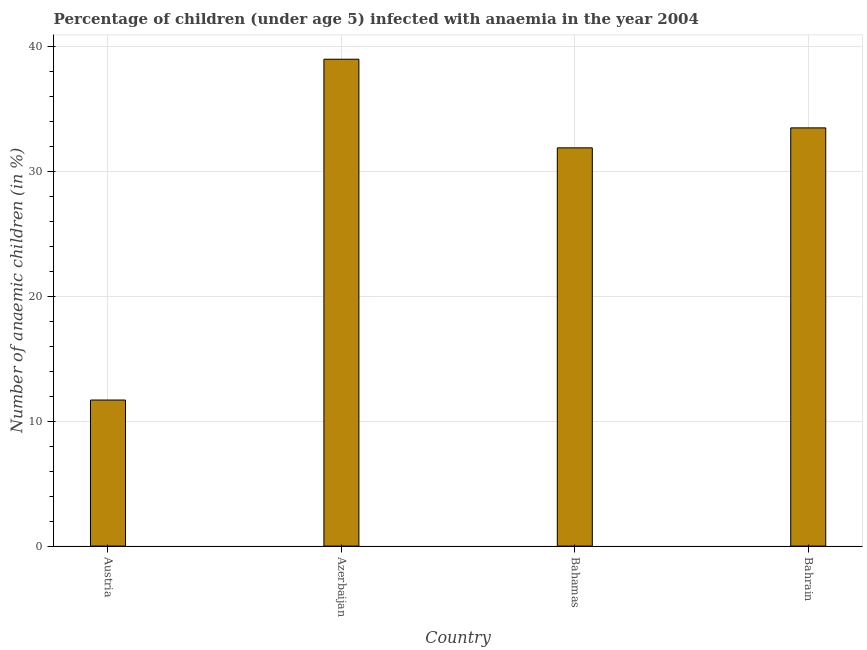What is the title of the graph?
Ensure brevity in your answer.  Percentage of children (under age 5) infected with anaemia in the year 2004. What is the label or title of the Y-axis?
Give a very brief answer. Number of anaemic children (in %). What is the number of anaemic children in Bahrain?
Provide a succinct answer. 33.5. Across all countries, what is the minimum number of anaemic children?
Provide a short and direct response. 11.7. In which country was the number of anaemic children maximum?
Make the answer very short. Azerbaijan. What is the sum of the number of anaemic children?
Ensure brevity in your answer.  116.1. What is the difference between the number of anaemic children in Austria and Bahamas?
Offer a terse response. -20.2. What is the average number of anaemic children per country?
Provide a short and direct response. 29.02. What is the median number of anaemic children?
Offer a very short reply. 32.7. In how many countries, is the number of anaemic children greater than 28 %?
Make the answer very short. 3. Is the number of anaemic children in Azerbaijan less than that in Bahrain?
Provide a short and direct response. No. What is the difference between the highest and the lowest number of anaemic children?
Your answer should be very brief. 27.3. Are all the bars in the graph horizontal?
Keep it short and to the point. No. How many countries are there in the graph?
Give a very brief answer. 4. What is the difference between two consecutive major ticks on the Y-axis?
Offer a very short reply. 10. Are the values on the major ticks of Y-axis written in scientific E-notation?
Offer a very short reply. No. What is the Number of anaemic children (in %) of Austria?
Keep it short and to the point. 11.7. What is the Number of anaemic children (in %) in Bahamas?
Your answer should be compact. 31.9. What is the Number of anaemic children (in %) in Bahrain?
Offer a terse response. 33.5. What is the difference between the Number of anaemic children (in %) in Austria and Azerbaijan?
Give a very brief answer. -27.3. What is the difference between the Number of anaemic children (in %) in Austria and Bahamas?
Ensure brevity in your answer.  -20.2. What is the difference between the Number of anaemic children (in %) in Austria and Bahrain?
Give a very brief answer. -21.8. What is the difference between the Number of anaemic children (in %) in Azerbaijan and Bahrain?
Make the answer very short. 5.5. What is the difference between the Number of anaemic children (in %) in Bahamas and Bahrain?
Keep it short and to the point. -1.6. What is the ratio of the Number of anaemic children (in %) in Austria to that in Bahamas?
Offer a terse response. 0.37. What is the ratio of the Number of anaemic children (in %) in Austria to that in Bahrain?
Keep it short and to the point. 0.35. What is the ratio of the Number of anaemic children (in %) in Azerbaijan to that in Bahamas?
Make the answer very short. 1.22. What is the ratio of the Number of anaemic children (in %) in Azerbaijan to that in Bahrain?
Give a very brief answer. 1.16. What is the ratio of the Number of anaemic children (in %) in Bahamas to that in Bahrain?
Offer a very short reply. 0.95. 